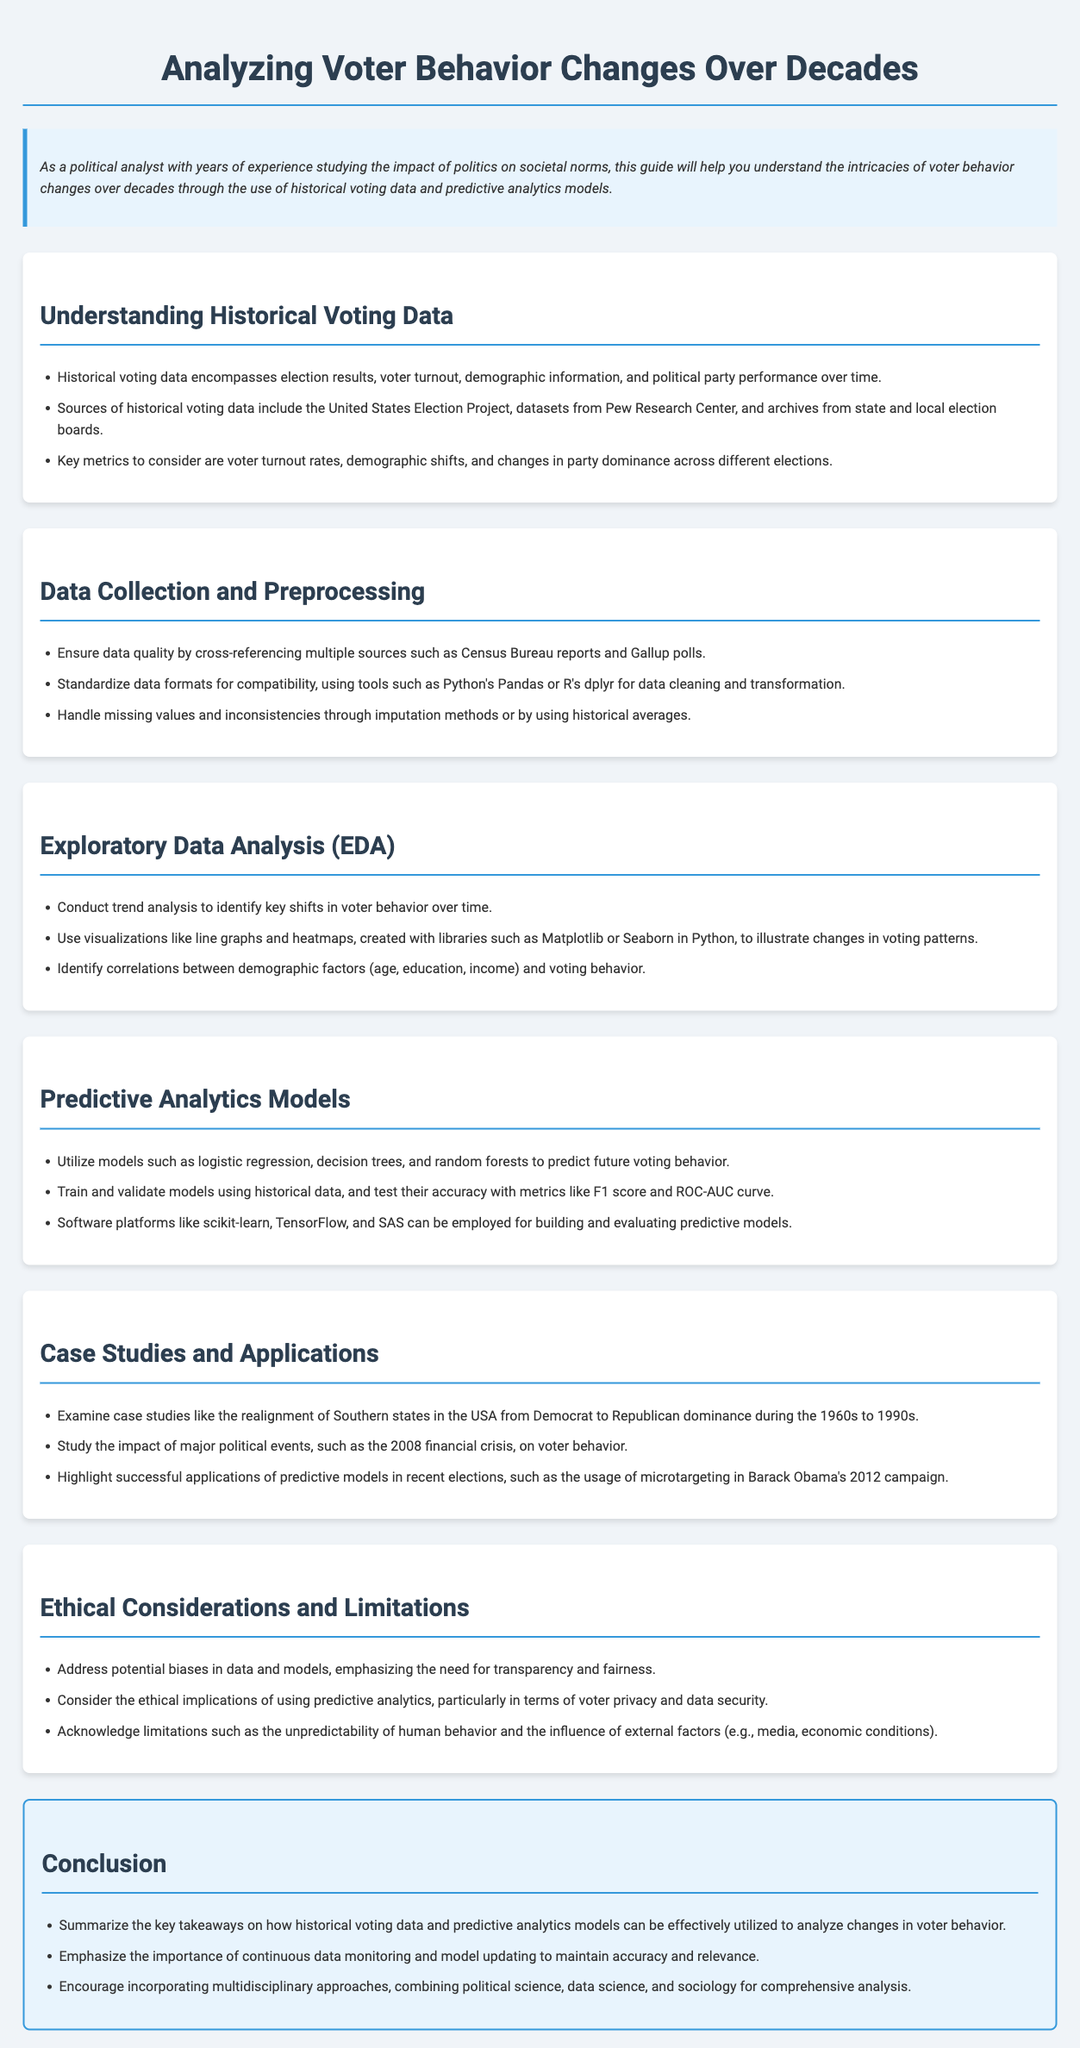What is the main focus of this user guide? The main focus is on understanding voter behavior changes over decades through historical voting data and predictive analytics models.
Answer: Analyzing voter behavior changes over decades What are two sources of historical voting data mentioned? The document lists specific sources including the United States Election Project and datasets from Pew Research Center.
Answer: United States Election Project, datasets from Pew Research Center What kind of models are suggested for predicting future voting behavior? The guide suggests using logistic regression, decision trees, and random forests as predictive models.
Answer: Logistic regression, decision trees, random forests Which visualization tools are recommended for exploratory data analysis? The document recommends using libraries such as Matplotlib and Seaborn for visualizations like line graphs and heatmaps.
Answer: Matplotlib, Seaborn What is one ethical consideration highlighted in the document? The document highlights the need to address potential biases in data and models, emphasizing transparency and fairness.
Answer: Potential biases in data and models What significant event's impact on voter behavior is studied in one of the case studies? The document indicates that the impact of the 2008 financial crisis on voter behavior is studied.
Answer: 2008 financial crisis Which approach is encouraged for comprehensive analysis? The guide encourages incorporating multidisciplinary approaches that combine political science, data science, and sociology.
Answer: Multidisciplinary approaches What is one key metric to consider in historical voting data? Voter turnout rates are mentioned as one of the key metrics to consider in the document.
Answer: Voter turnout rates What is one method suggested for handling missing data? The guide suggests using imputation methods or historical averages to handle missing values and inconsistencies.
Answer: Imputation methods or historical averages 